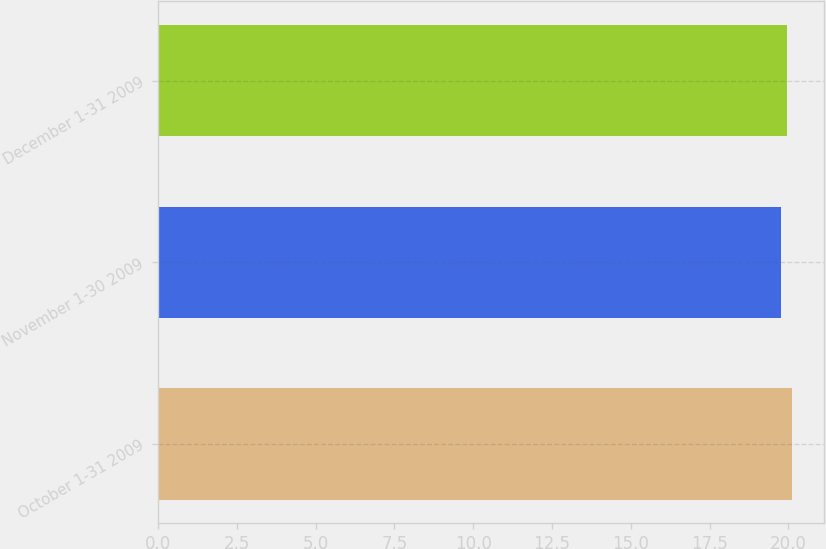Convert chart to OTSL. <chart><loc_0><loc_0><loc_500><loc_500><bar_chart><fcel>October 1-31 2009<fcel>November 1-30 2009<fcel>December 1-31 2009<nl><fcel>20.12<fcel>19.75<fcel>19.96<nl></chart> 